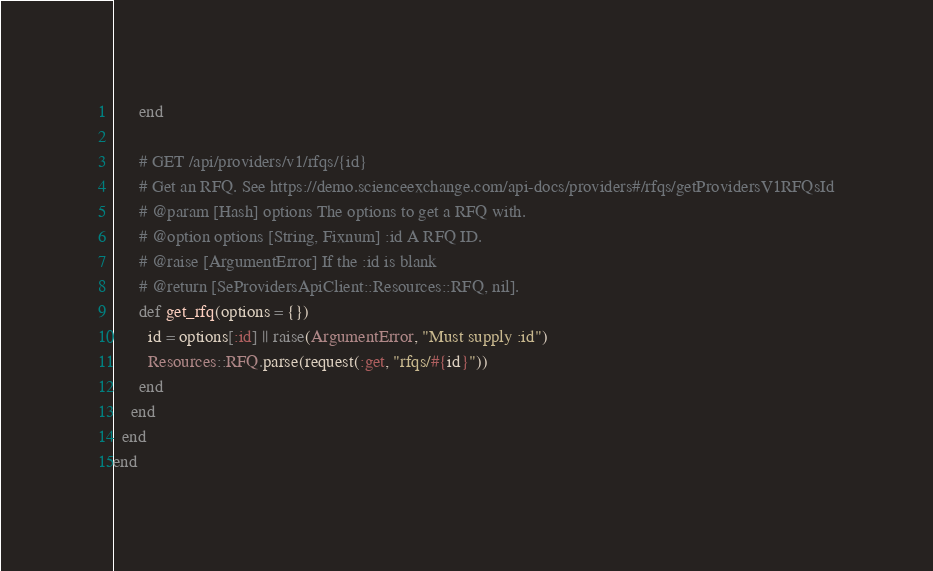<code> <loc_0><loc_0><loc_500><loc_500><_Ruby_>      end

      # GET /api/providers/v1/rfqs/{id}
      # Get an RFQ. See https://demo.scienceexchange.com/api-docs/providers#/rfqs/getProvidersV1RFQsId
      # @param [Hash] options The options to get a RFQ with.
      # @option options [String, Fixnum] :id A RFQ ID.
      # @raise [ArgumentError] If the :id is blank
      # @return [SeProvidersApiClient::Resources::RFQ, nil].
      def get_rfq(options = {})
        id = options[:id] || raise(ArgumentError, "Must supply :id")
        Resources::RFQ.parse(request(:get, "rfqs/#{id}"))
      end
    end
  end
end
</code> 